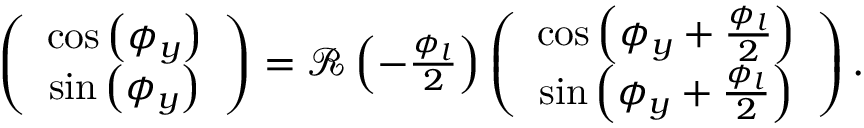Convert formula to latex. <formula><loc_0><loc_0><loc_500><loc_500>\begin{array} { r } { \left ( \begin{array} { c } { \cos \left ( \phi _ { y } \right ) } \\ { \sin \left ( \phi _ { y } \right ) } \end{array} \right ) = { \mathcal { R } } \left ( - \frac { \phi _ { l } } { 2 } \right ) \left ( \begin{array} { c } { \cos \left ( \phi _ { y } + \frac { \phi _ { l } } { 2 } \right ) } \\ { \sin \left ( \phi _ { y } + \frac { \phi _ { l } } { 2 } \right ) } \end{array} \right ) . } \end{array}</formula> 